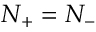<formula> <loc_0><loc_0><loc_500><loc_500>N _ { + } = N _ { - }</formula> 